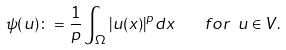Convert formula to latex. <formula><loc_0><loc_0><loc_500><loc_500>\psi ( u ) \colon = \frac { 1 } { p } \int _ { \Omega } | u ( x ) | ^ { p } d x \quad f o r \ u \in V .</formula> 